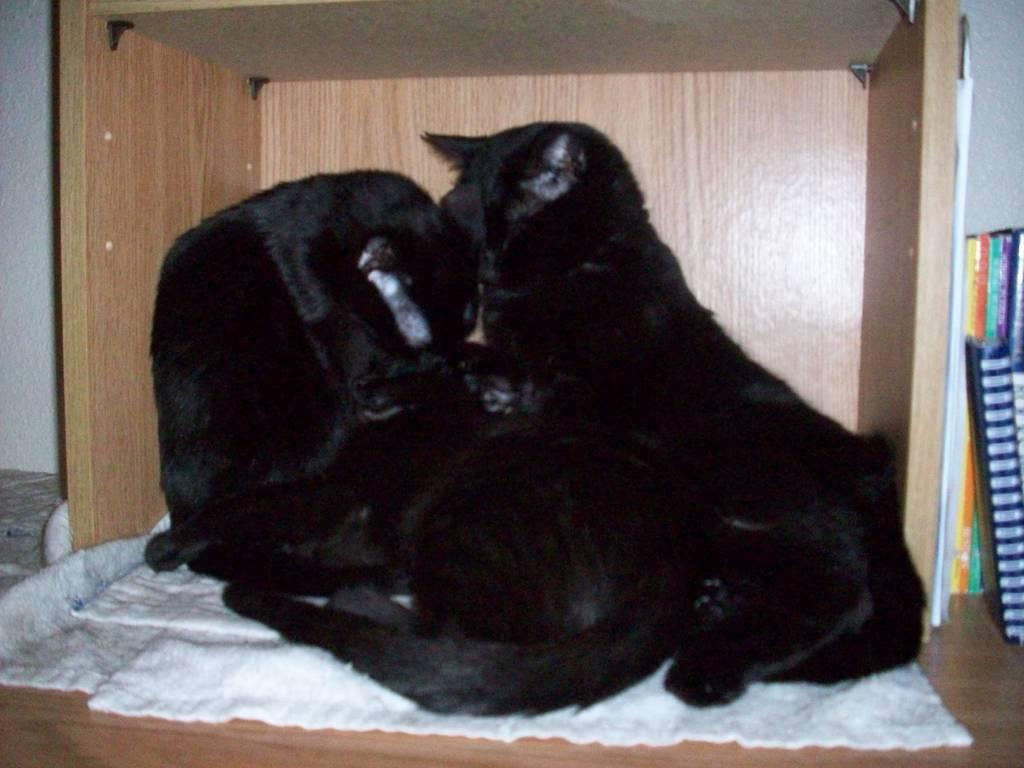Describe this image in one or two sentences. In this image we can see black cats on the wooden table, there is a white towel, on the right, there are books, at the back there is a wall. 